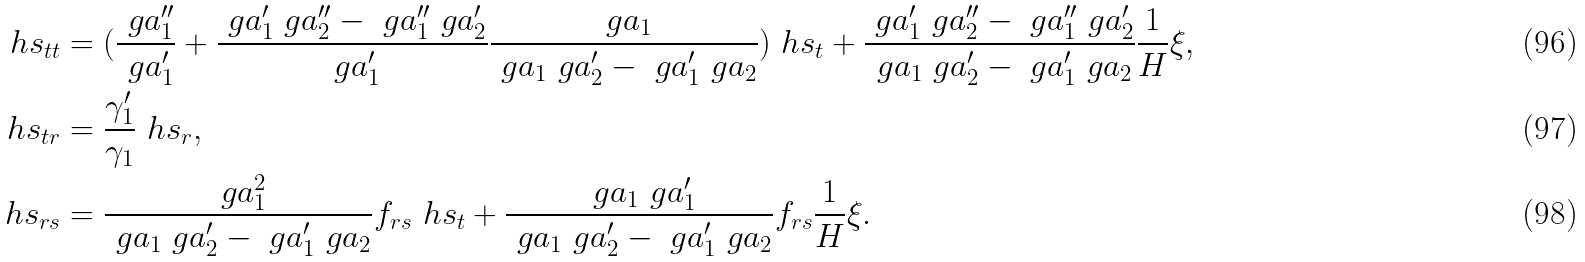Convert formula to latex. <formula><loc_0><loc_0><loc_500><loc_500>\ h s _ { t t } & = ( \frac { \ g a _ { 1 } ^ { \prime \prime } } { \ g a _ { 1 } ^ { \prime } } + \frac { \ g a _ { 1 } ^ { \prime } \ g a _ { 2 } ^ { \prime \prime } - \ g a _ { 1 } ^ { \prime \prime } \ g a _ { 2 } ^ { \prime } } { \ g a _ { 1 } ^ { \prime } } \frac { \ g a _ { 1 } } { \ g a _ { 1 } \ g a _ { 2 } ^ { \prime } - \ g a _ { 1 } ^ { \prime } \ g a _ { 2 } } ) \ h s _ { t } + \frac { \ g a _ { 1 } ^ { \prime } \ g a _ { 2 } ^ { \prime \prime } - \ g a _ { 1 } ^ { \prime \prime } \ g a _ { 2 } ^ { \prime } } { \ g a _ { 1 } \ g a _ { 2 } ^ { \prime } - \ g a _ { 1 } ^ { \prime } \ g a _ { 2 } } \frac { 1 } { H } \xi , \\ \ h s _ { t r } & = \frac { \gamma _ { 1 } ^ { \prime } } { \gamma _ { 1 } } \ h s _ { r } , \\ \ h s _ { r s } & = \frac { \ g a _ { 1 } ^ { 2 } } { \ g a _ { 1 } \ g a _ { 2 } ^ { \prime } - \ g a _ { 1 } ^ { \prime } \ g a _ { 2 } } f _ { r s } \ h s _ { t } + \frac { \ g a _ { 1 } \ g a _ { 1 } ^ { \prime } } { \ g a _ { 1 } \ g a _ { 2 } ^ { \prime } - \ g a _ { 1 } ^ { \prime } \ g a _ { 2 } } f _ { r s } \frac { 1 } { H } \xi .</formula> 